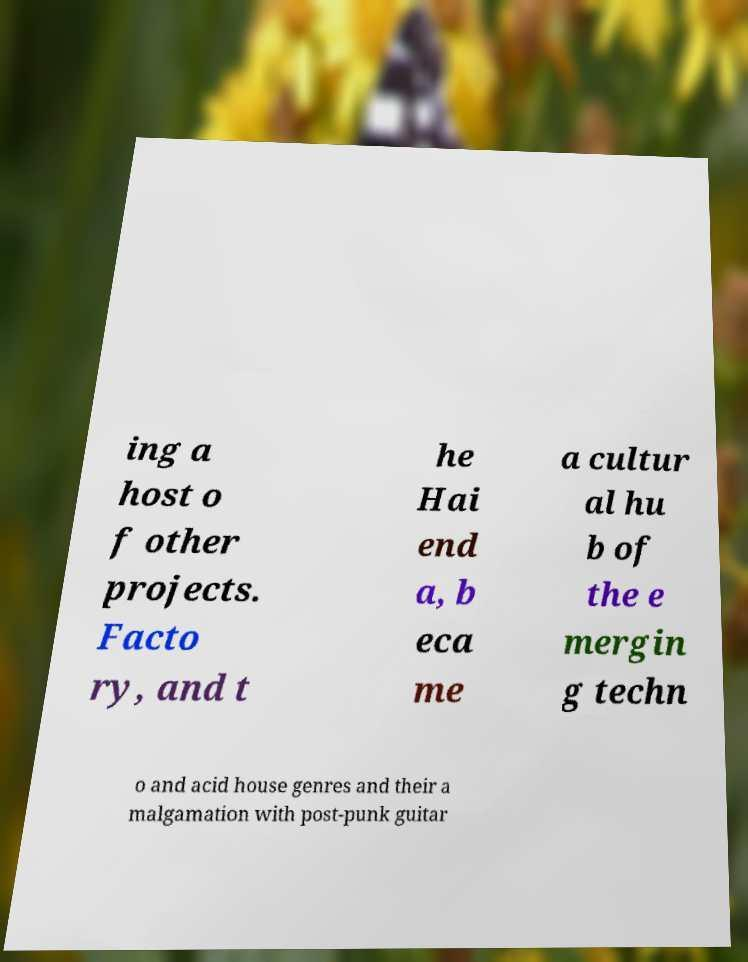Can you accurately transcribe the text from the provided image for me? ing a host o f other projects. Facto ry, and t he Hai end a, b eca me a cultur al hu b of the e mergin g techn o and acid house genres and their a malgamation with post-punk guitar 